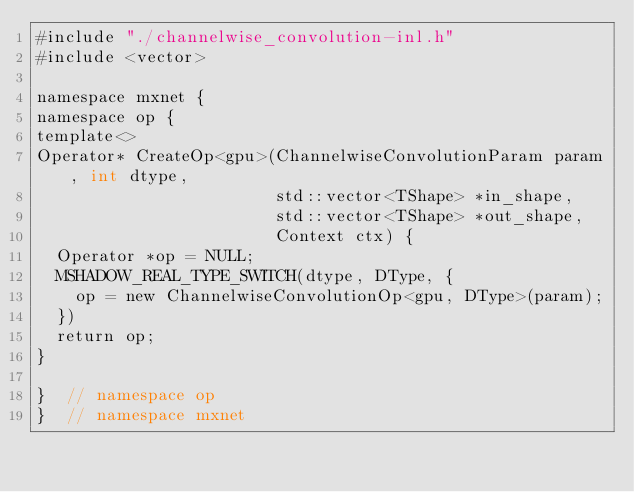<code> <loc_0><loc_0><loc_500><loc_500><_Cuda_>#include "./channelwise_convolution-inl.h"
#include <vector>

namespace mxnet {
namespace op {
template<>
Operator* CreateOp<gpu>(ChannelwiseConvolutionParam param, int dtype,
                        std::vector<TShape> *in_shape,
                        std::vector<TShape> *out_shape,
                        Context ctx) {
  Operator *op = NULL;
  MSHADOW_REAL_TYPE_SWITCH(dtype, DType, {
    op = new ChannelwiseConvolutionOp<gpu, DType>(param);
  })
  return op;
}

}  // namespace op
}  // namespace mxnet

</code> 